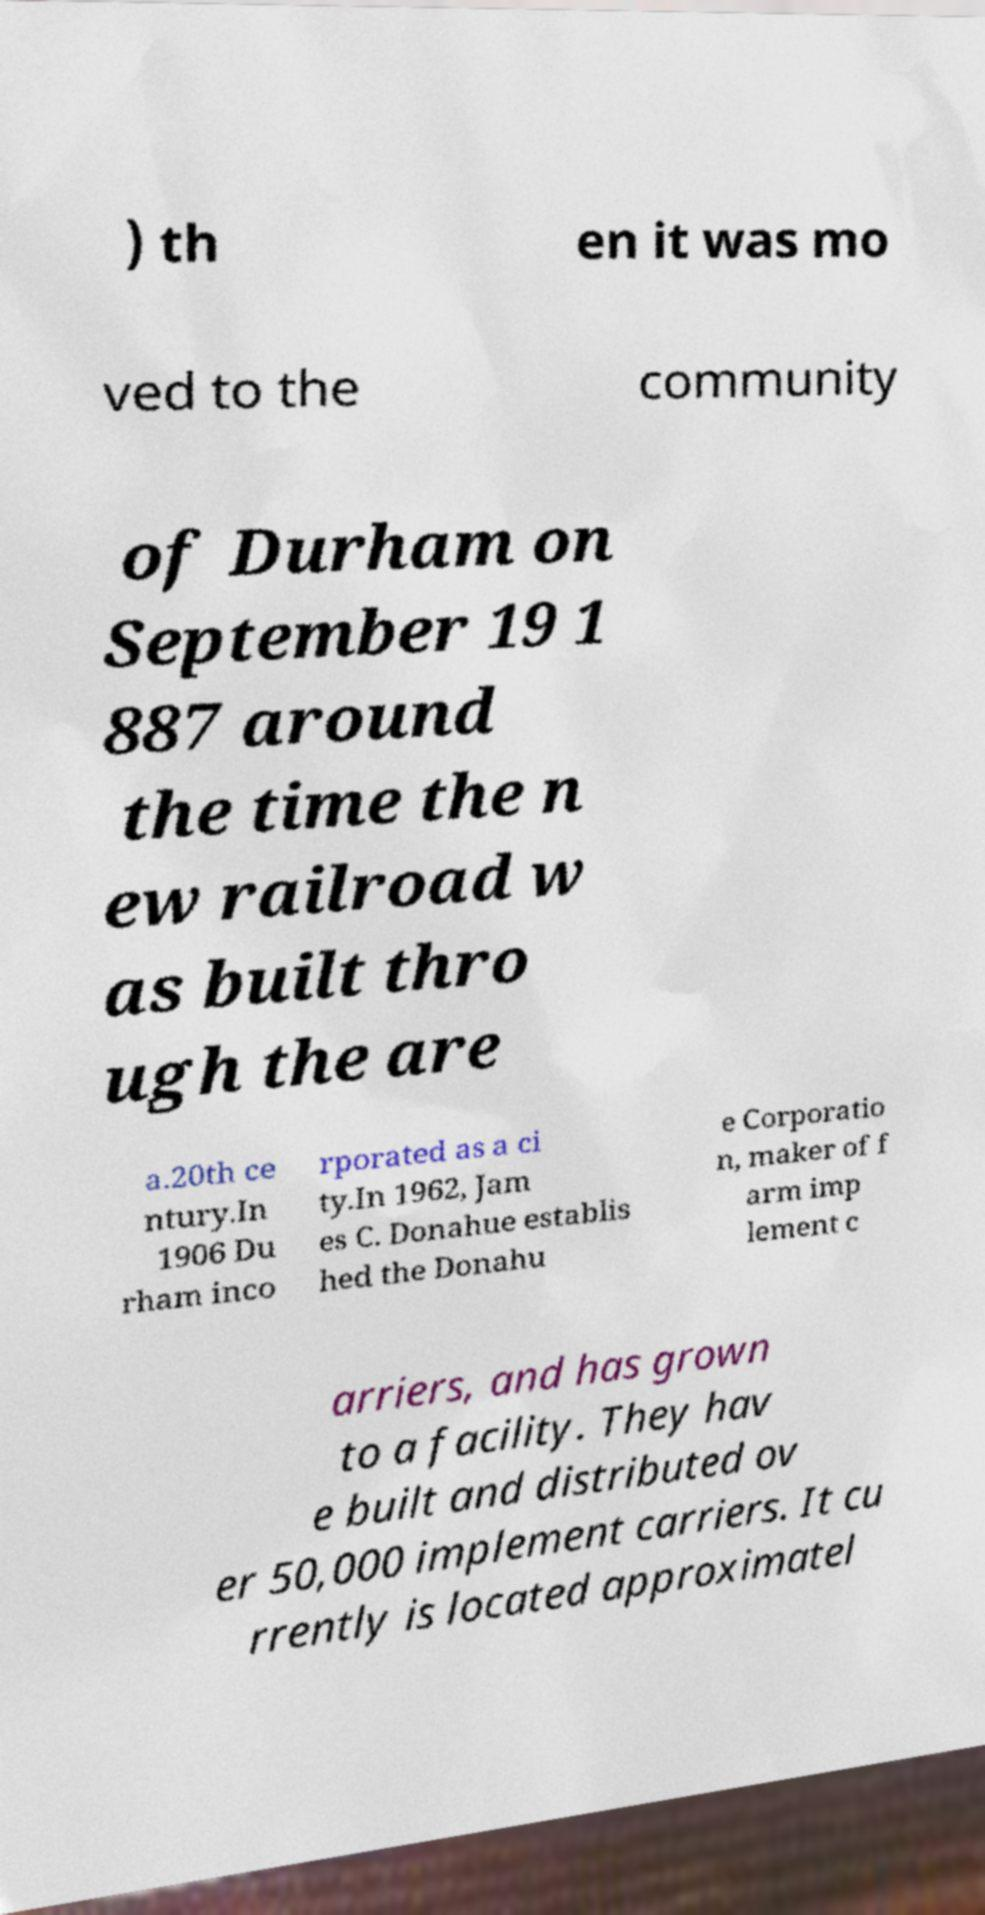Can you accurately transcribe the text from the provided image for me? ) th en it was mo ved to the community of Durham on September 19 1 887 around the time the n ew railroad w as built thro ugh the are a.20th ce ntury.In 1906 Du rham inco rporated as a ci ty.In 1962, Jam es C. Donahue establis hed the Donahu e Corporatio n, maker of f arm imp lement c arriers, and has grown to a facility. They hav e built and distributed ov er 50,000 implement carriers. It cu rrently is located approximatel 